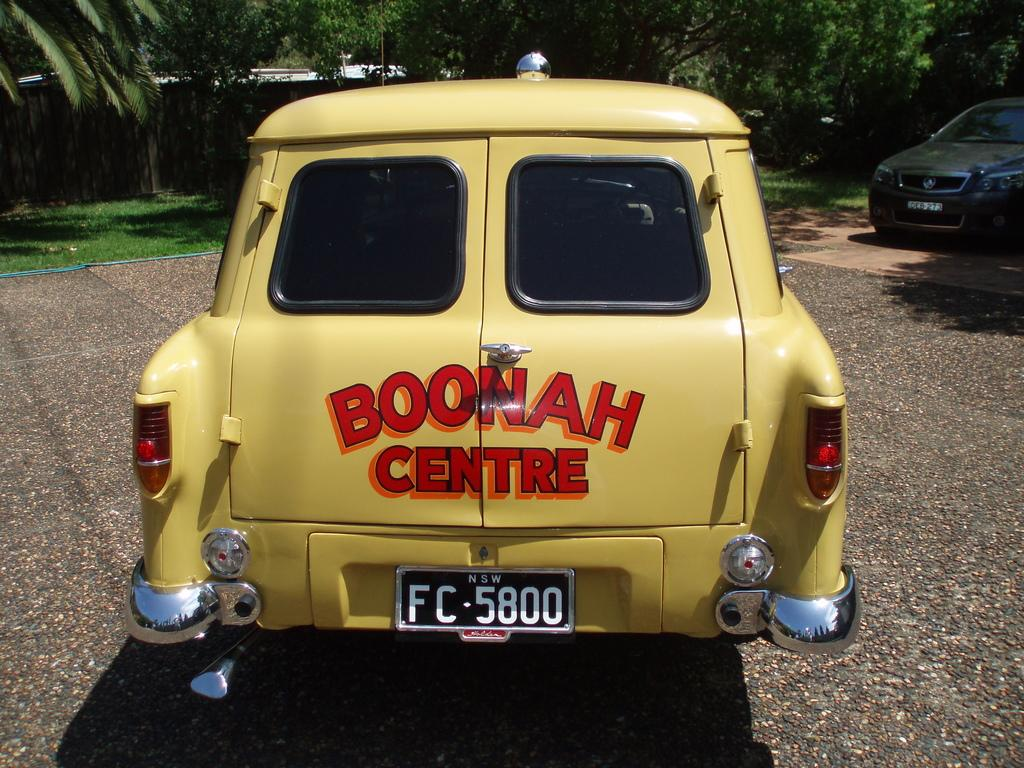What type of vehicles are on the ground in the image? There are cars on the ground in the image. What natural elements can be seen in the image? There are trees and grass in the image. What type of ship can be seen sailing in the image? There is no ship present in the image; it only features cars, trees, and grass. 